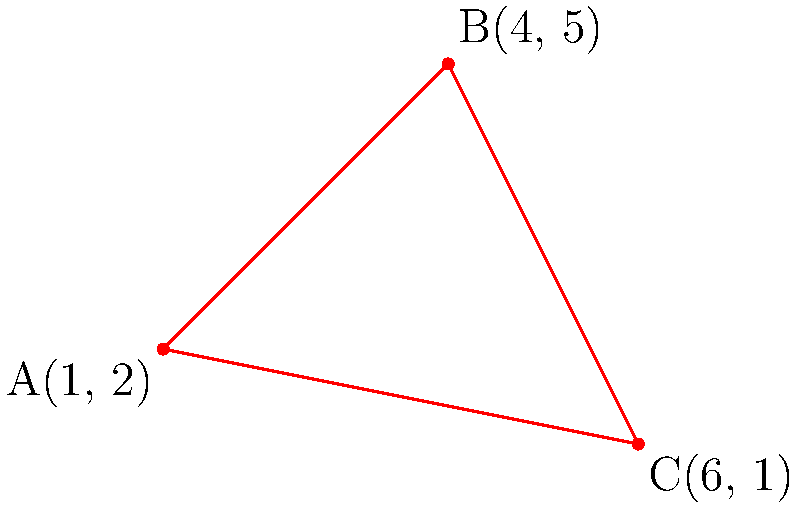In a park, a triangular area has been identified as a potential danger zone due to falling tree branches. The corners of this area are marked by three points: A(1, 2), B(4, 5), and C(6, 1). As an epidemiologist studying outdoor injuries, you need to calculate the area of this danger zone to assess the risk and plan preventive measures. Using the coordinates provided, determine the area of the triangular danger zone in square units. To find the area of a triangle given three coordinate points, we can use the formula:

$$ \text{Area} = \frac{1}{2}|x_1(y_2 - y_3) + x_2(y_3 - y_1) + x_3(y_1 - y_2)| $$

Where $(x_1, y_1)$, $(x_2, y_2)$, and $(x_3, y_3)$ are the coordinates of the three points.

Given:
A(1, 2), B(4, 5), C(6, 1)

Step 1: Identify the coordinates
$(x_1, y_1) = (1, 2)$
$(x_2, y_2) = (4, 5)$
$(x_3, y_3) = (6, 1)$

Step 2: Substitute the values into the formula
$$ \text{Area} = \frac{1}{2}|1(5 - 1) + 4(1 - 2) + 6(2 - 5)| $$

Step 3: Simplify the expression inside the absolute value bars
$$ \text{Area} = \frac{1}{2}|1(4) + 4(-1) + 6(-3)| $$
$$ \text{Area} = \frac{1}{2}|4 - 4 - 18| $$
$$ \text{Area} = \frac{1}{2}|-18| $$

Step 4: Calculate the final result
$$ \text{Area} = \frac{1}{2}(18) = 9 $$

Therefore, the area of the triangular danger zone is 9 square units.
Answer: 9 square units 